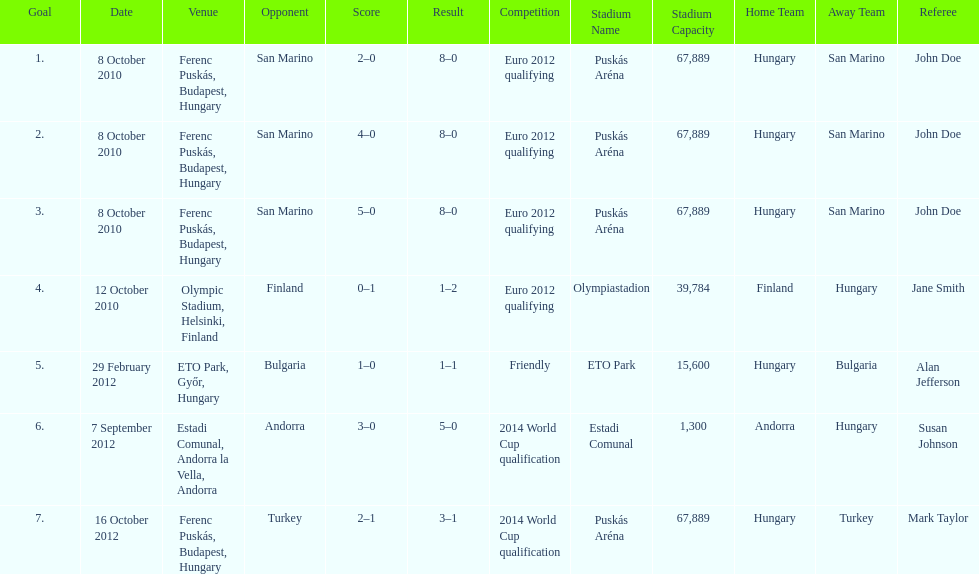Help me parse the entirety of this table. {'header': ['Goal', 'Date', 'Venue', 'Opponent', 'Score', 'Result', 'Competition', 'Stadium Name', 'Stadium Capacity', 'Home Team', 'Away Team', 'Referee'], 'rows': [['1.', '8 October 2010', 'Ferenc Puskás, Budapest, Hungary', 'San Marino', '2–0', '8–0', 'Euro 2012 qualifying', 'Puskás Aréna', '67,889', 'Hungary', 'San Marino', 'John Doe'], ['2.', '8 October 2010', 'Ferenc Puskás, Budapest, Hungary', 'San Marino', '4–0', '8–0', 'Euro 2012 qualifying', 'Puskás Aréna', '67,889', 'Hungary', 'San Marino', 'John Doe'], ['3.', '8 October 2010', 'Ferenc Puskás, Budapest, Hungary', 'San Marino', '5–0', '8–0', 'Euro 2012 qualifying', 'Puskás Aréna', '67,889', 'Hungary', 'San Marino', 'John Doe'], ['4.', '12 October 2010', 'Olympic Stadium, Helsinki, Finland', 'Finland', '0–1', '1–2', 'Euro 2012 qualifying', 'Olympiastadion', '39,784', 'Finland', 'Hungary', 'Jane Smith'], ['5.', '29 February 2012', 'ETO Park, Győr, Hungary', 'Bulgaria', '1–0', '1–1', 'Friendly', 'ETO Park', '15,600', 'Hungary', 'Bulgaria', 'Alan Jefferson'], ['6.', '7 September 2012', 'Estadi Comunal, Andorra la Vella, Andorra', 'Andorra', '3–0', '5–0', '2014 World Cup qualification', 'Estadi Comunal', '1,300', 'Andorra', 'Hungary', 'Susan Johnson'], ['7.', '16 October 2012', 'Ferenc Puskás, Budapest, Hungary', 'Turkey', '2–1', '3–1', '2014 World Cup qualification', 'Puskás Aréna', '67,889', 'Hungary', 'Turkey', 'Mark Taylor']]} In what year was szalai's first international goal? 2010. 